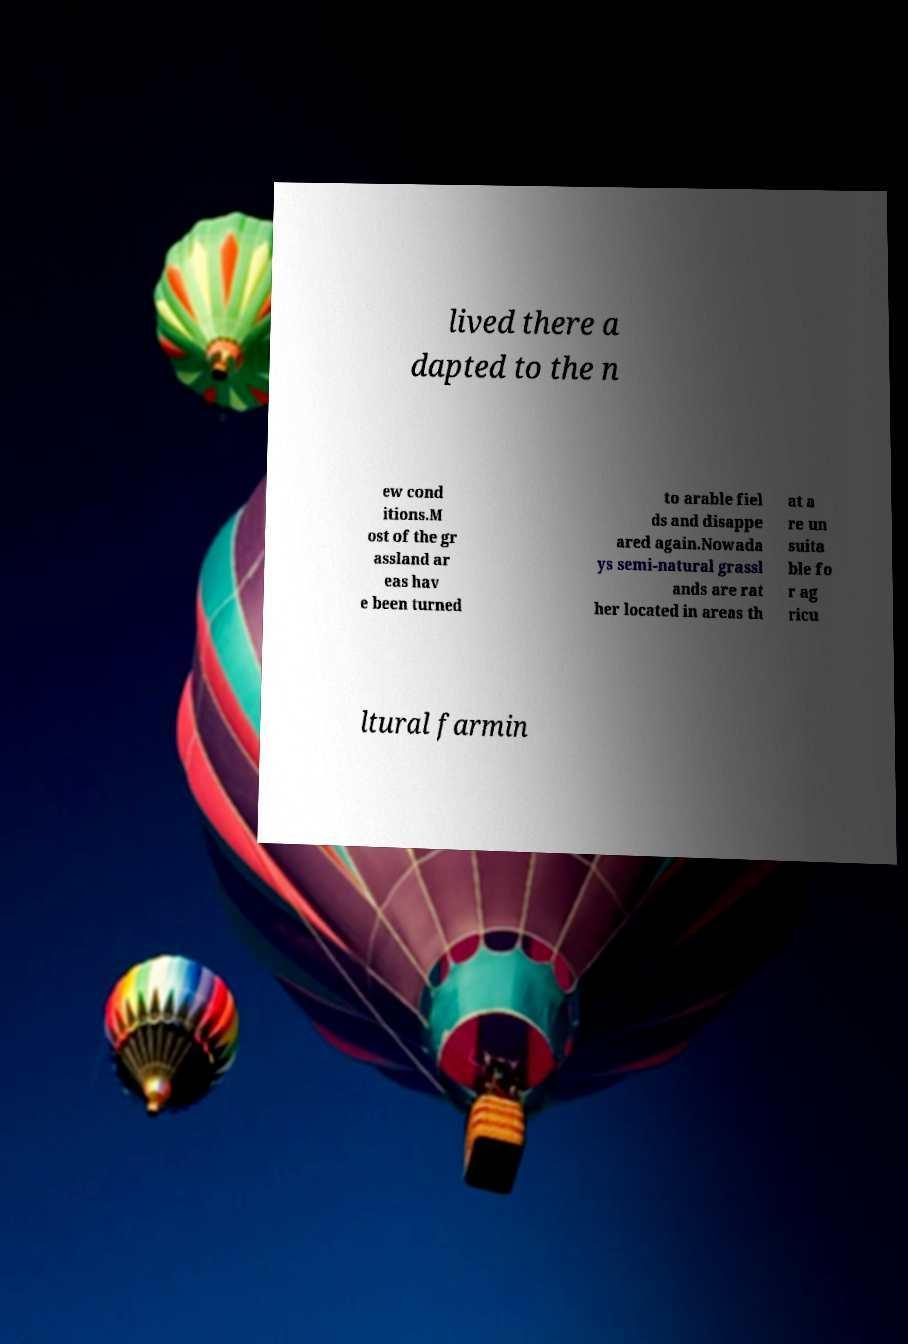For documentation purposes, I need the text within this image transcribed. Could you provide that? lived there a dapted to the n ew cond itions.M ost of the gr assland ar eas hav e been turned to arable fiel ds and disappe ared again.Nowada ys semi-natural grassl ands are rat her located in areas th at a re un suita ble fo r ag ricu ltural farmin 